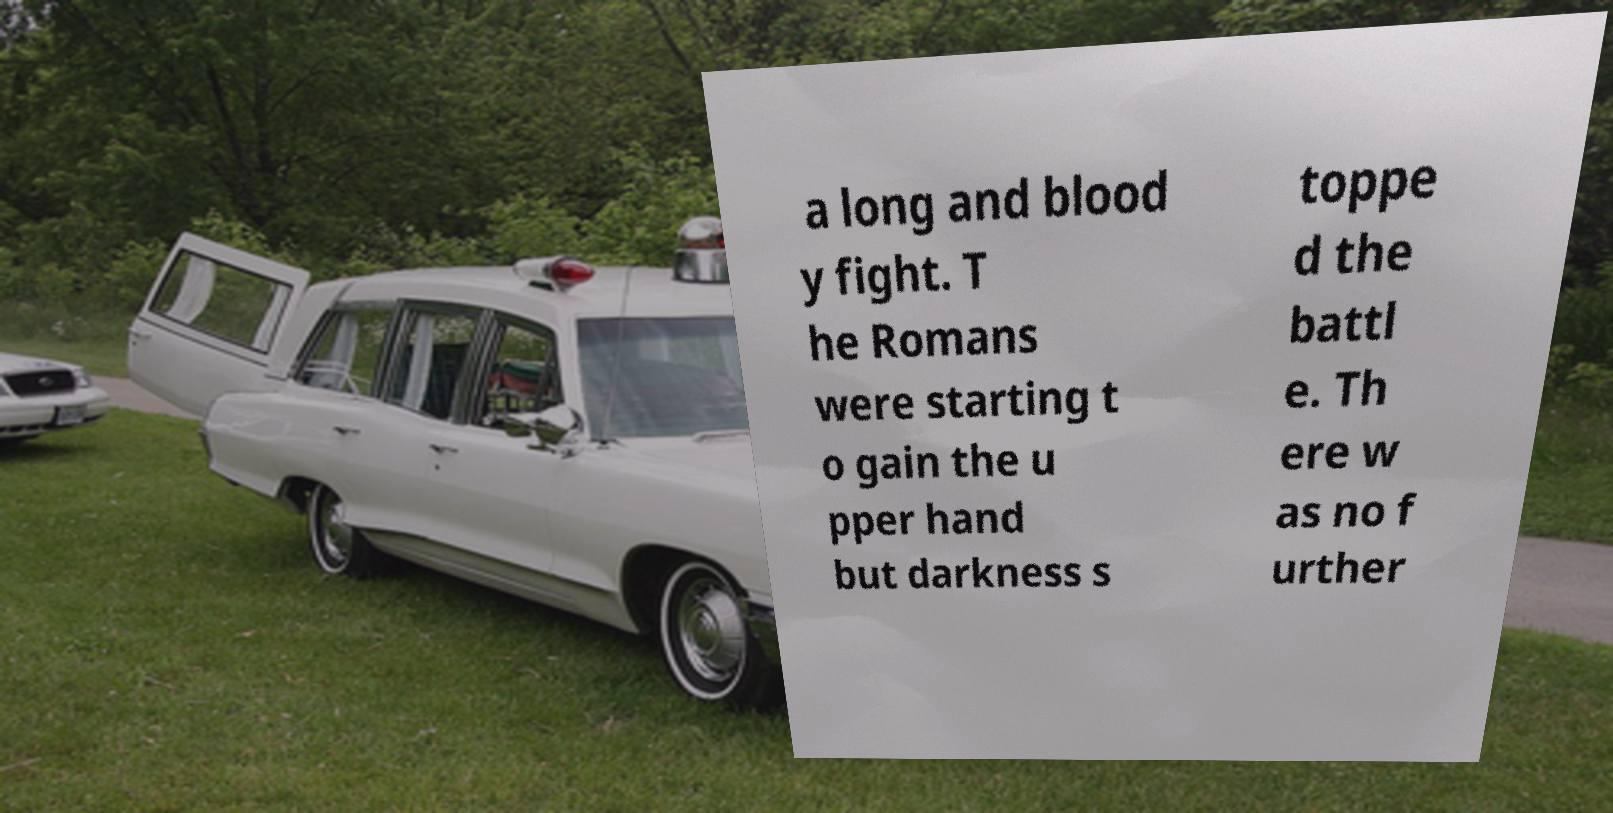What messages or text are displayed in this image? I need them in a readable, typed format. a long and blood y fight. T he Romans were starting t o gain the u pper hand but darkness s toppe d the battl e. Th ere w as no f urther 